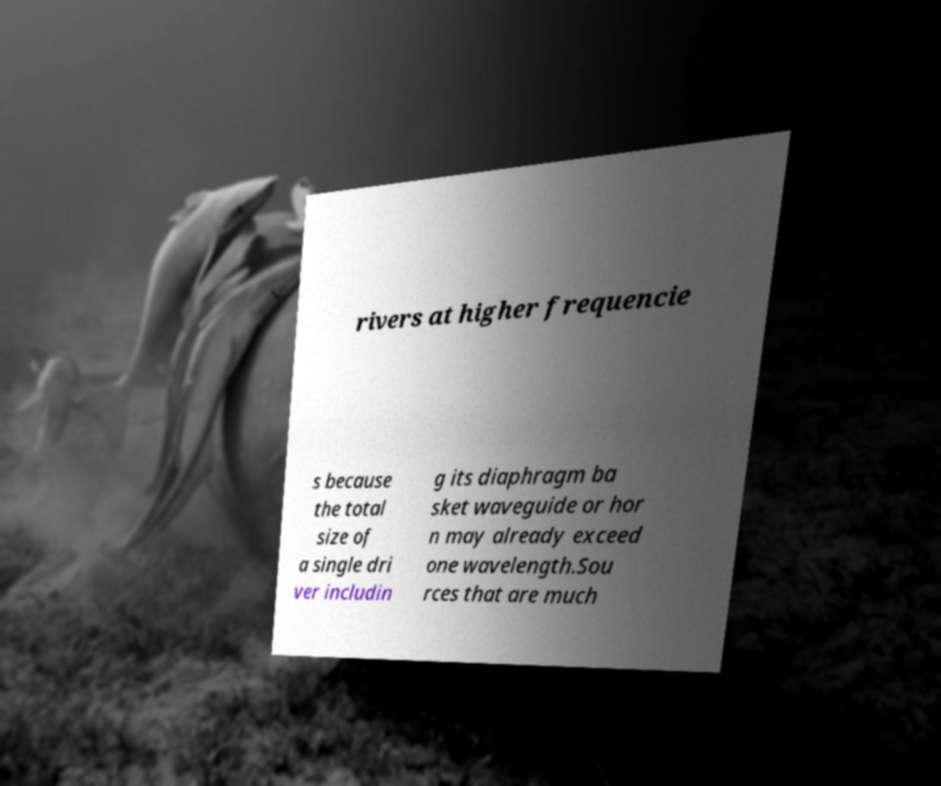Can you read and provide the text displayed in the image?This photo seems to have some interesting text. Can you extract and type it out for me? rivers at higher frequencie s because the total size of a single dri ver includin g its diaphragm ba sket waveguide or hor n may already exceed one wavelength.Sou rces that are much 